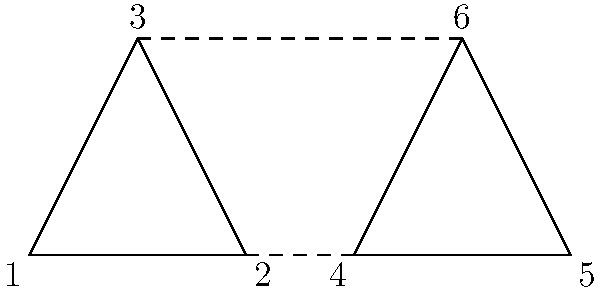In a functional movement exercise, an athlete transitions from a triangular stance (1-2-3) to another triangular stance (4-5-6). This transformation preserves the shape and orientation of the triangle but changes its position. Which group theory concept best describes this transformation, and what is the order of this transformation group? To answer this question, let's analyze the transformation step-by-step:

1. The transformation preserves the shape and orientation of the triangle, moving it from one position to another.

2. This type of transformation is known as a translation in group theory. It moves every point of the object by the same distance in the same direction.

3. Translations form a group under composition, known as the translation group.

4. The translation group has the following properties:
   a. Closure: Composing two translations results in another translation.
   b. Associativity: $(T_1 \circ T_2) \circ T_3 = T_1 \circ (T_2 \circ T_3)$
   c. Identity: The identity transformation (no movement) is a translation.
   d. Inverse: Every translation has an inverse (moving back to the original position).

5. The order of a group is the number of elements in the group.

6. For translations in a two-dimensional plane, there are infinitely many possible translations (in any direction and by any distance).

7. Therefore, the translation group in two dimensions is infinite and continuous.
Answer: Translation group; infinite order 